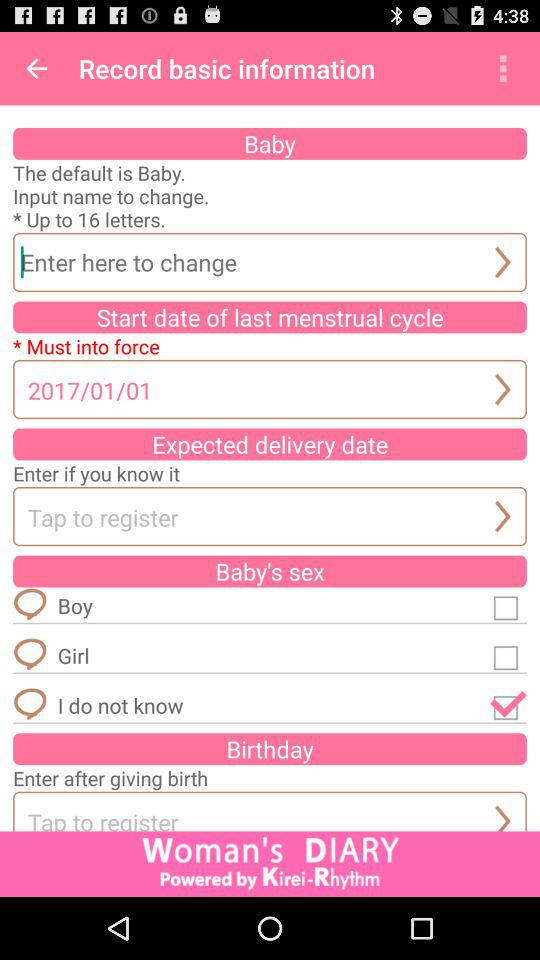How many letters can be entered in a name? The number of letters that can be entered is 16. 